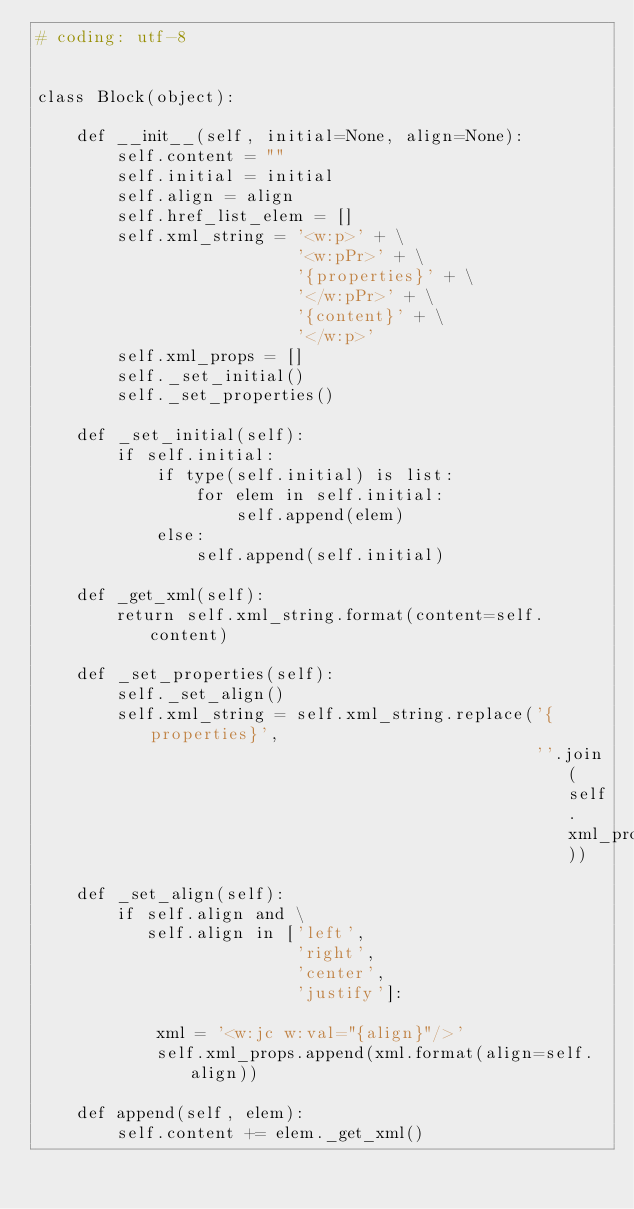Convert code to text. <code><loc_0><loc_0><loc_500><loc_500><_Python_># coding: utf-8


class Block(object):

    def __init__(self, initial=None, align=None):
        self.content = ""
        self.initial = initial
        self.align = align
        self.href_list_elem = []
        self.xml_string = '<w:p>' + \
                          '<w:pPr>' + \
                          '{properties}' + \
                          '</w:pPr>' + \
                          '{content}' + \
                          '</w:p>'
        self.xml_props = []
        self._set_initial()
        self._set_properties()

    def _set_initial(self):
        if self.initial:
            if type(self.initial) is list:
                for elem in self.initial:
                    self.append(elem)
            else:
                self.append(self.initial)

    def _get_xml(self):
        return self.xml_string.format(content=self.content)

    def _set_properties(self):
        self._set_align()
        self.xml_string = self.xml_string.replace('{properties}',
                                                  ''.join(self.xml_props))

    def _set_align(self):
        if self.align and \
           self.align in ['left',
                          'right',
                          'center',
                          'justify']:

            xml = '<w:jc w:val="{align}"/>'
            self.xml_props.append(xml.format(align=self.align))

    def append(self, elem):
        self.content += elem._get_xml()
</code> 